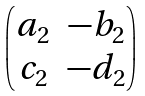Convert formula to latex. <formula><loc_0><loc_0><loc_500><loc_500>\begin{pmatrix} a _ { 2 } & - b _ { 2 } \\ c _ { 2 } & - d _ { 2 } \end{pmatrix}</formula> 